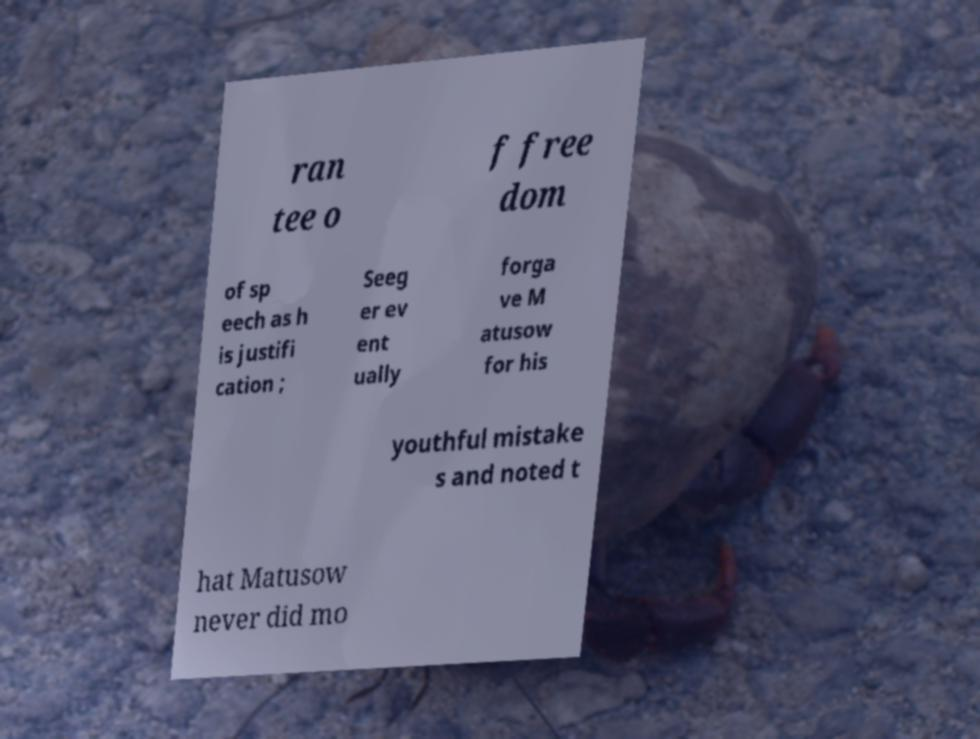Please identify and transcribe the text found in this image. ran tee o f free dom of sp eech as h is justifi cation ; Seeg er ev ent ually forga ve M atusow for his youthful mistake s and noted t hat Matusow never did mo 